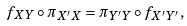<formula> <loc_0><loc_0><loc_500><loc_500>f _ { X Y } \circ \pi _ { X ^ { \prime } X } = \pi _ { Y ^ { \prime } Y } \circ f _ { X ^ { \prime } Y ^ { \prime } } ,</formula> 